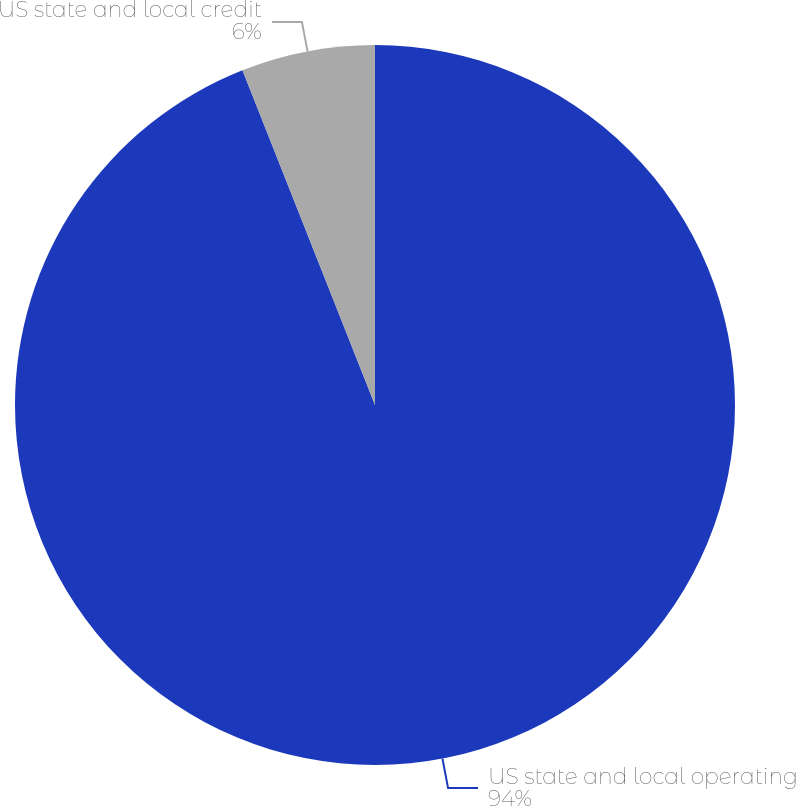Convert chart. <chart><loc_0><loc_0><loc_500><loc_500><pie_chart><fcel>US state and local operating<fcel>US state and local credit<nl><fcel>94.0%<fcel>6.0%<nl></chart> 